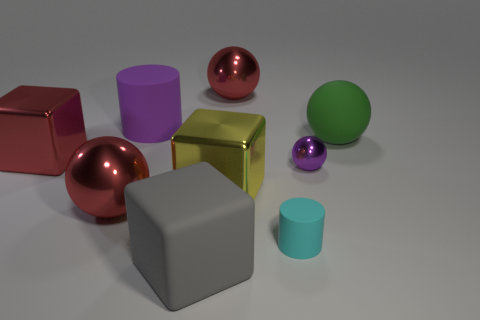What is the material of the red cube?
Keep it short and to the point. Metal. Is the color of the small object behind the small cylinder the same as the large rubber cylinder to the left of the large gray object?
Make the answer very short. Yes. Is the number of small cyan matte things greater than the number of large gray cylinders?
Provide a short and direct response. Yes. How many small metal things are the same color as the tiny rubber object?
Offer a very short reply. 0. There is a large matte thing that is the same shape as the yellow metallic object; what color is it?
Provide a short and direct response. Gray. There is a large block that is both behind the gray block and on the right side of the purple rubber cylinder; what material is it?
Keep it short and to the point. Metal. Do the red object in front of the yellow metallic thing and the cylinder that is on the left side of the big rubber cube have the same material?
Your response must be concise. No. What is the size of the cyan rubber object?
Offer a terse response. Small. The purple thing that is the same shape as the cyan matte thing is what size?
Provide a succinct answer. Large. What number of large red objects are on the right side of the large cylinder?
Keep it short and to the point. 1. 